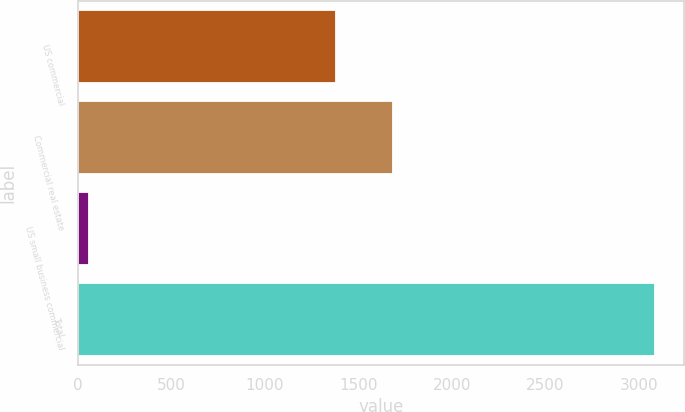Convert chart to OTSL. <chart><loc_0><loc_0><loc_500><loc_500><bar_chart><fcel>US commercial<fcel>Commercial real estate<fcel>US small business commercial<fcel>Total<nl><fcel>1381<fcel>1683.9<fcel>58<fcel>3087<nl></chart> 